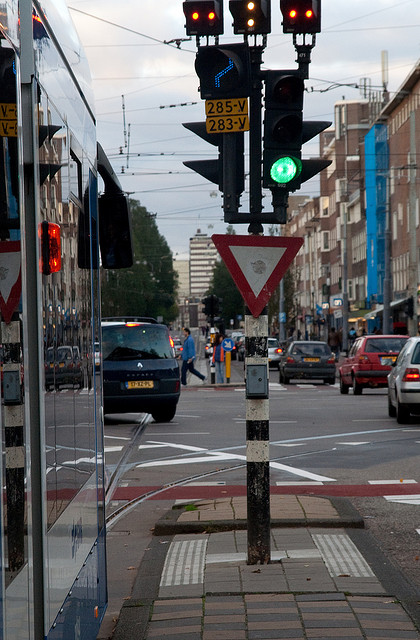Identify the text displayed in this image. 285 V 283 V 